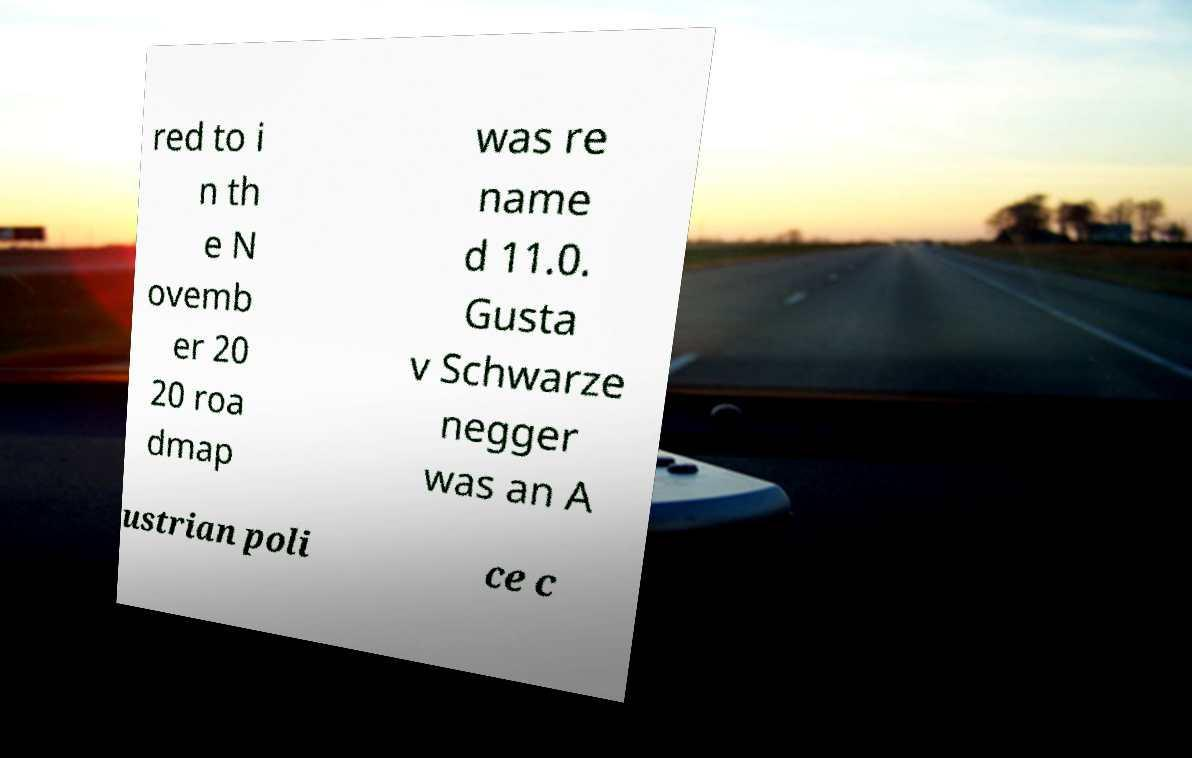For documentation purposes, I need the text within this image transcribed. Could you provide that? red to i n th e N ovemb er 20 20 roa dmap was re name d 11.0. Gusta v Schwarze negger was an A ustrian poli ce c 